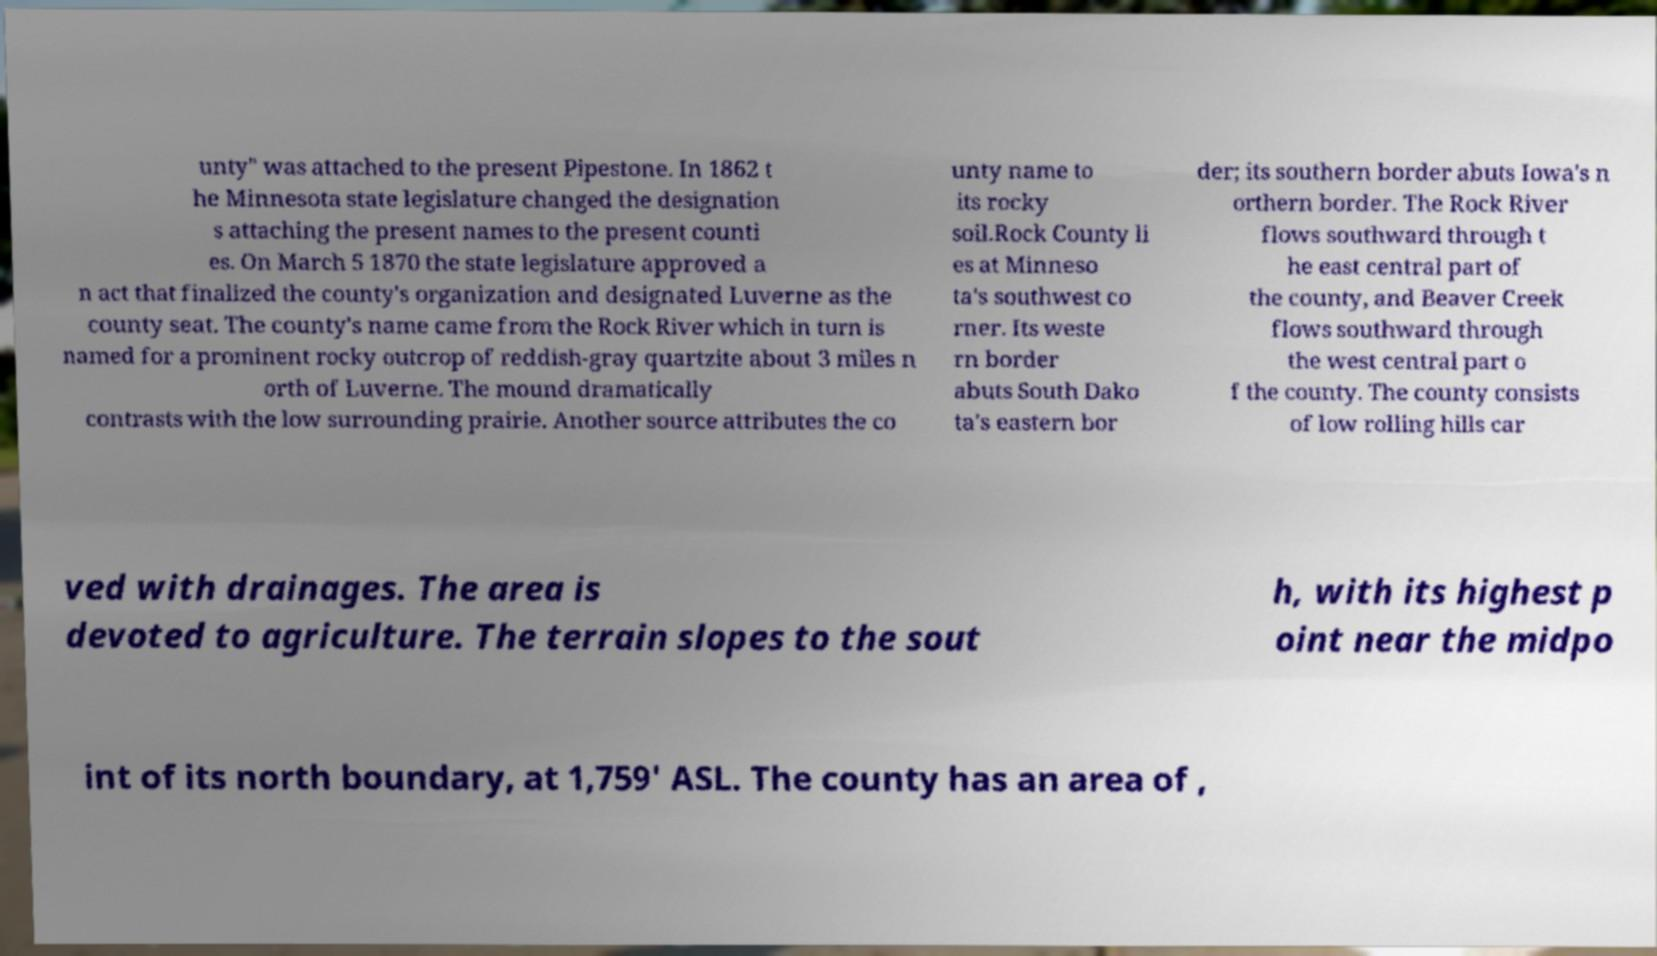I need the written content from this picture converted into text. Can you do that? unty" was attached to the present Pipestone. In 1862 t he Minnesota state legislature changed the designation s attaching the present names to the present counti es. On March 5 1870 the state legislature approved a n act that finalized the county's organization and designated Luverne as the county seat. The county's name came from the Rock River which in turn is named for a prominent rocky outcrop of reddish-gray quartzite about 3 miles n orth of Luverne. The mound dramatically contrasts with the low surrounding prairie. Another source attributes the co unty name to its rocky soil.Rock County li es at Minneso ta's southwest co rner. Its weste rn border abuts South Dako ta's eastern bor der; its southern border abuts Iowa's n orthern border. The Rock River flows southward through t he east central part of the county, and Beaver Creek flows southward through the west central part o f the county. The county consists of low rolling hills car ved with drainages. The area is devoted to agriculture. The terrain slopes to the sout h, with its highest p oint near the midpo int of its north boundary, at 1,759' ASL. The county has an area of , 